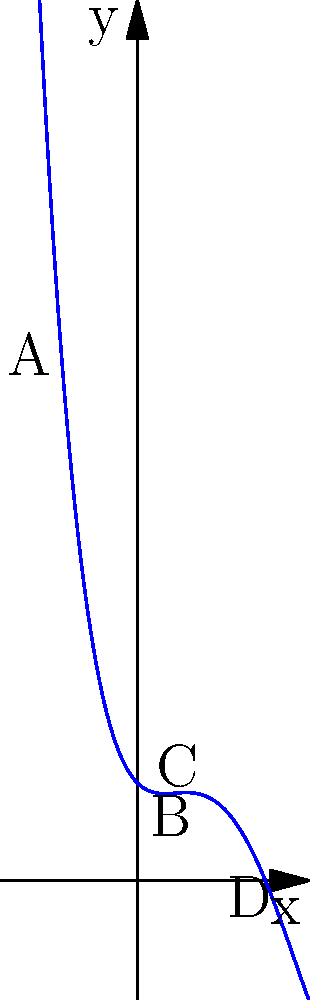The graph above represents the acoustic wave of Garth Brooks' hit song "Friends in Low Places". If this wave is modeled by the polynomial function $f(x) = 0.1x^4 - 0.8x^3 + 1.5x^2 - x + 2$, which point(s) on the graph could represent the intense chorus of the song? To determine which point(s) could represent the intense chorus of the song, we need to analyze the graph and understand what intensity means in terms of the acoustic wave:

1. In an acoustic wave, higher amplitude (y-value) typically represents higher intensity or volume.

2. Looking at the graph, we can see four labeled points: A, B, C, and D.

3. Let's compare their y-values:
   - Point A: Has a relatively low y-value
   - Point B: Has the lowest y-value among the labeled points
   - Point C: Has the highest y-value among the labeled points
   - Point D: Has a relatively high y-value, but not as high as C

4. Since the chorus is typically the most intense part of a song, it would likely correspond to the point with the highest amplitude.

5. Point C has the highest y-value, indicating the highest amplitude and thus the highest intensity.

Therefore, Point C is the most likely to represent the intense chorus of "Friends in Low Places".
Answer: Point C 